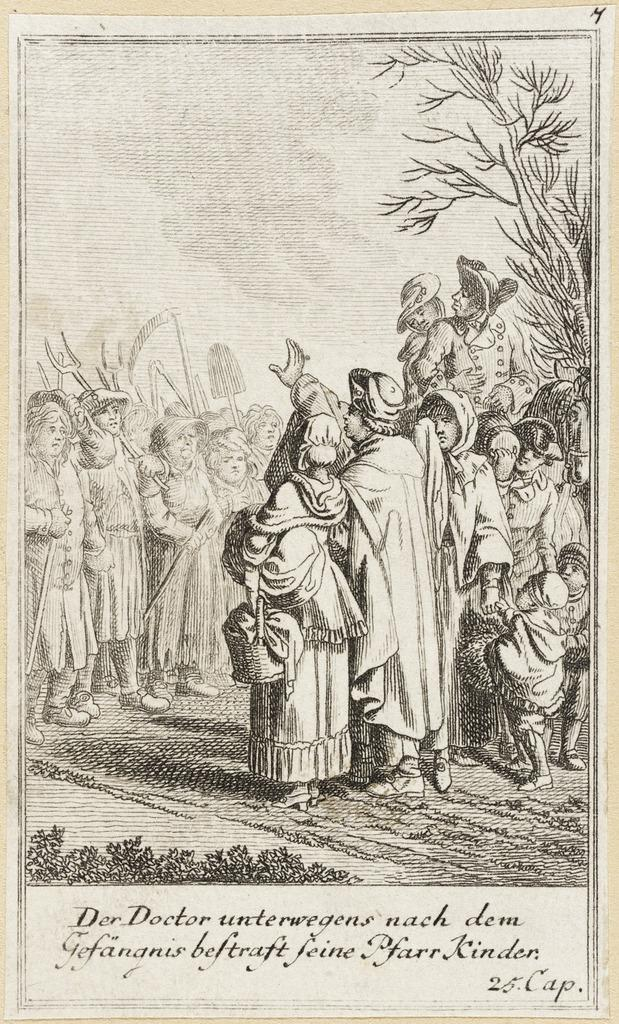What is happening in the image? There are persons standing in the image. What are the persons holding in their hands? The persons are holding an object in their hands. Can you describe any additional information about the image? There is text written below the image. What type of tramp can be seen jumping in the image? There is no tramp present in the image; it features persons standing and holding an object. What kind of cover is protecting the carpenter in the image? There is no carpenter or cover present in the image. 